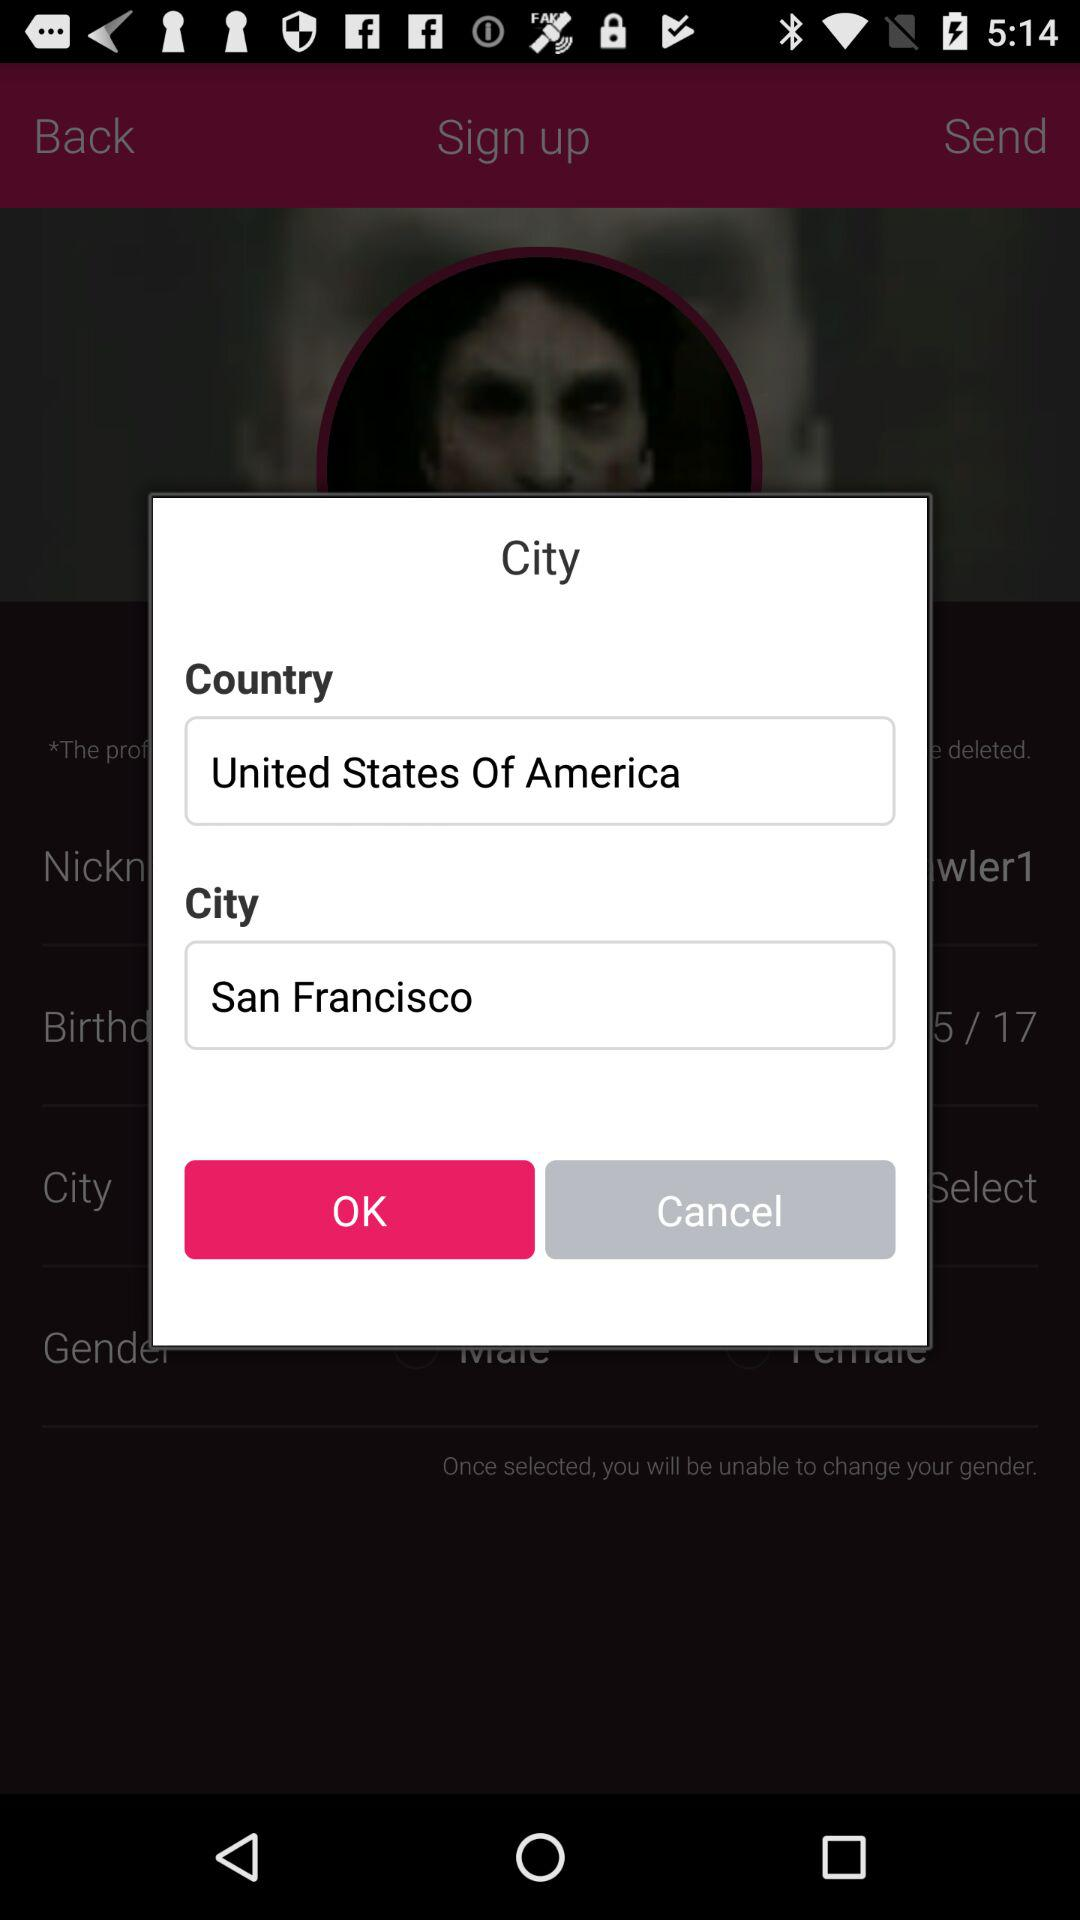What is the country name? The country name is the United States of America. 